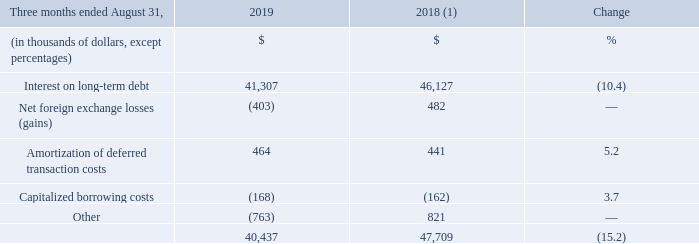FINANCIAL EXPENSE
(1) Fiscal 2018 was restated to reclassify results from Cogeco Peer 1 as discontinued operations. For further details, please consult the "Discontinued operations" section.
Fiscal 2019 fourth-quarter financial expense decreased by 15.2% mainly due to: • the reimbursements of $65 million and US$35 million under the Canadian Revolving Facility during the second quarter of fiscal 2019 and of US$328 million during the third quarter of fiscal 2019 following the sale of Cogeco Peer 1; and • lower debt outstanding and interest rates on the First Lien Credit Facilities; party offset by • the appreciation of the US dollar against the Canadian dollar compared to same period of the prior year.
What was the financial expense decrease in fourth-quarter 2019? 15.2%. What was the reimbursement in 2019 fourth quarter? $65 million and us$35 million. What was the percentage decrease in the interest on long-term debt from 2018 to 2019?
Answer scale should be: percent. 10.4. What was the increase / (decrease) in the interest on long-term debt from 2018 to 2019?
Answer scale should be: thousand. 41,307 - 46,127
Answer: -4820. What was the average Amortization of deferred transaction costs from 2018 to 2019?
Answer scale should be: thousand. (464 + 441) / 2
Answer: 452.5. What was the increase / (decrease) in total financial expense from 2018 to 2019?
Answer scale should be: thousand. 40,437 - 47,709
Answer: -7272. 